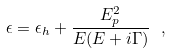Convert formula to latex. <formula><loc_0><loc_0><loc_500><loc_500>\epsilon = \epsilon _ { h } + \frac { E _ { p } ^ { 2 } } { E ( E + i \Gamma ) } \ ,</formula> 